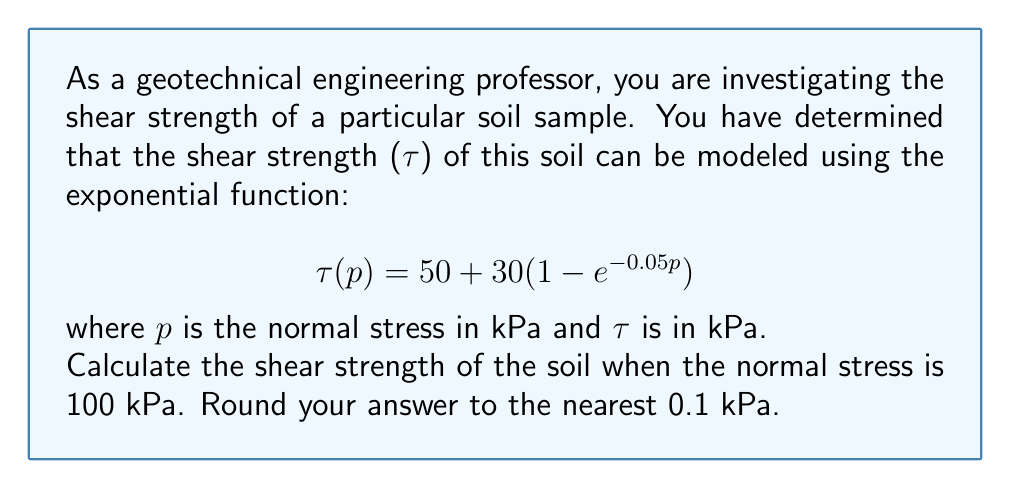Teach me how to tackle this problem. To solve this problem, we need to follow these steps:

1) We are given the exponential function for shear strength:
   $$\tau(p) = 50 + 30(1 - e^{-0.05p})$$

2) We need to calculate $\tau$ when $p = 100$ kPa:
   $$\tau(100) = 50 + 30(1 - e^{-0.05(100)})$$

3) Let's evaluate the exponential part first:
   $$e^{-0.05(100)} = e^{-5} \approx 0.00674$$

4) Now, let's substitute this back into our equation:
   $$\tau(100) = 50 + 30(1 - 0.00674)$$
   $$\tau(100) = 50 + 30(0.99326)$$

5) Simplify:
   $$\tau(100) = 50 + 29.7978$$
   $$\tau(100) = 79.7978$$

6) Rounding to the nearest 0.1 kPa:
   $$\tau(100) \approx 79.8 \text{ kPa}$$

Therefore, the shear strength of the soil when the normal stress is 100 kPa is approximately 79.8 kPa.
Answer: 79.8 kPa 